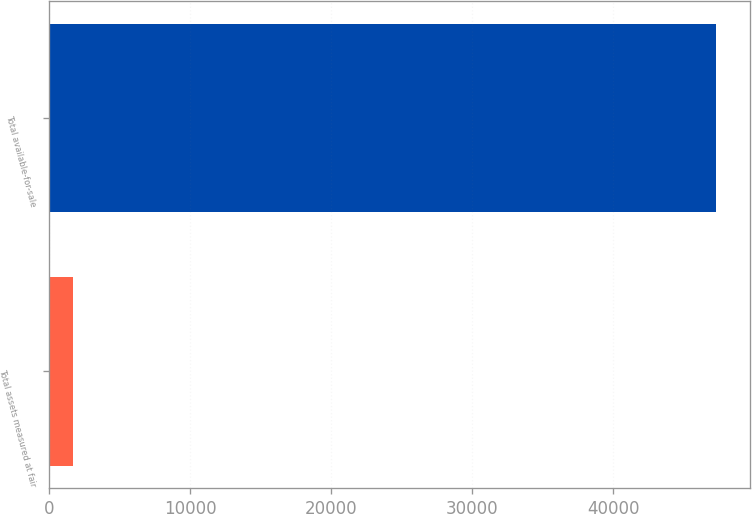<chart> <loc_0><loc_0><loc_500><loc_500><bar_chart><fcel>Total assets measured at fair<fcel>Total available-for-sale<nl><fcel>1721<fcel>47310<nl></chart> 